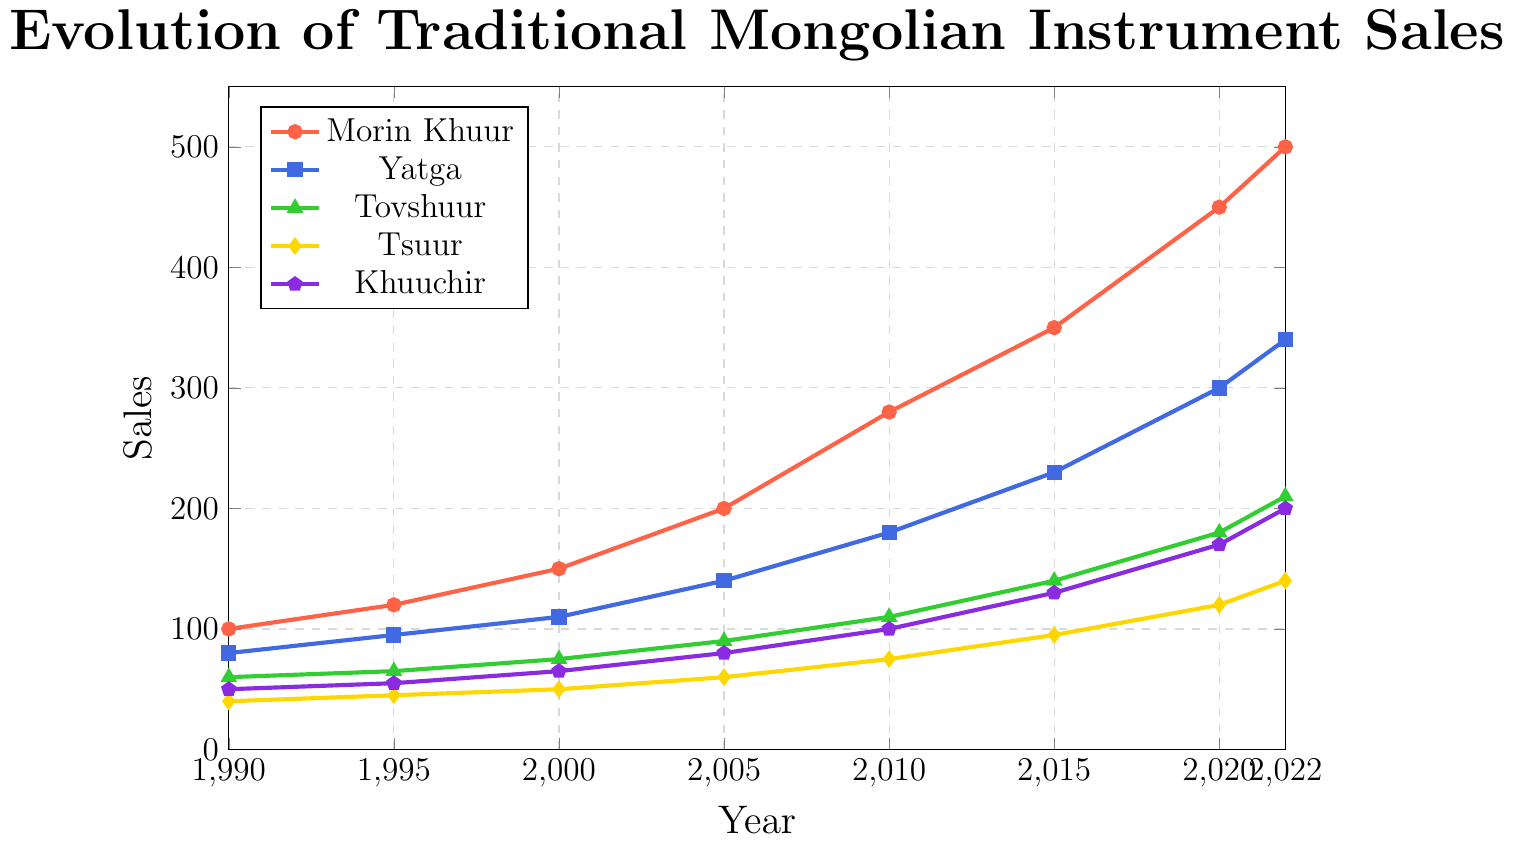How many more Morin Khuur were sold in 2022 compared to 1990? To find out how many more Morin Khuur were sold in 2022 compared to 1990, subtract the number of Morin Khuur sold in 1990 (100) from those sold in 2022 (500): 500 - 100 = 400
Answer: 400 Which instrument had the highest sales in 2020? To determine which instrument had the highest sales in 2020, compare the sales figures for each instrument in that year:
- Morin Khuur: 450
- Yatga: 300
- Tovshuur: 180
- Tsuur: 120
- Khuuchir: 170
The Morin Khuur had the highest sales with 450 units.
Answer: Morin Khuur What is the difference between the highest and lowest sales recorded across all instruments in 2010? First, find the highest and lowest sales figures for 2010:
- Highest: Morin Khuur with 280
- Lowest: Tsuur with 75
Then, compute the difference: 280 - 75 = 205
Answer: 205 Which instrument showed the greatest increase in sales from 2015 to 2020? Calculate the sales increase for each instrument from 2015 to 2020:
- Morin Khuur: 450 - 350 = 100
- Yatga: 300 - 230 = 70
- Tovshuur: 180 - 140 = 40
- Tsuur: 120 - 95 = 25
- Khuuchir: 170 - 130 = 40
The Morin Khuur showed the greatest increase in sales with 100 units.
Answer: Morin Khuur What is the average sales of Yatga from 1990 to 2022? Compute the average of Yatga sales over the given years:
(80 + 95 + 110 + 140 + 180 + 230 + 300 + 340) / 8 = 184.375
Answer: 184.375 Which instrument had the smallest sales in 1990? Compare the sales figures for each instrument in 1990:
- Morin Khuur: 100
- Yatga: 80
- Tovshuur: 60
- Tsuur: 40
- Khuuchir: 50
The Tsuur had the smallest sales with 40 units.
Answer: Tsuur 